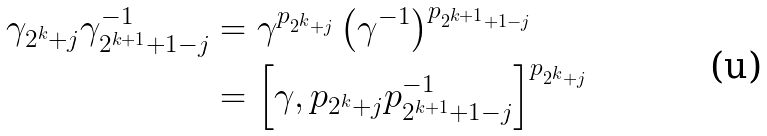Convert formula to latex. <formula><loc_0><loc_0><loc_500><loc_500>\gamma _ { 2 ^ { k } + j } \gamma _ { 2 ^ { k + 1 } + 1 - j } ^ { - 1 } & = \gamma ^ { p _ { 2 ^ { k } + j } } \left ( \gamma ^ { - 1 } \right ) ^ { p _ { 2 ^ { k + 1 } + 1 - j } } \\ & = \left [ \gamma , p _ { 2 ^ { k } + j } p _ { 2 ^ { k + 1 } + 1 - j } ^ { - 1 } \right ] ^ { p _ { 2 ^ { k } + j } }</formula> 